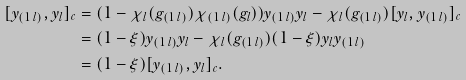Convert formula to latex. <formula><loc_0><loc_0><loc_500><loc_500>[ y _ { ( 1 \, l ) } , y _ { l } ] _ { c } & = ( 1 - \chi _ { l } ( g _ { ( 1 \, l ) } ) \chi _ { ( 1 \, l ) } ( g _ { l } ) ) y _ { ( 1 \, l ) } y _ { l } - \chi _ { l } ( g _ { ( 1 \, l ) } ) [ y _ { l } , y _ { ( 1 \, l ) } ] _ { c } \\ & = ( 1 - \xi ) y _ { ( 1 \, l ) } y _ { l } - \chi _ { l } ( g _ { ( 1 \, l ) } ) ( 1 - \xi ) y _ { l } y _ { ( 1 \, l ) } \\ & = ( 1 - \xi ) [ y _ { ( 1 \, l ) } , y _ { l } ] _ { c } .</formula> 